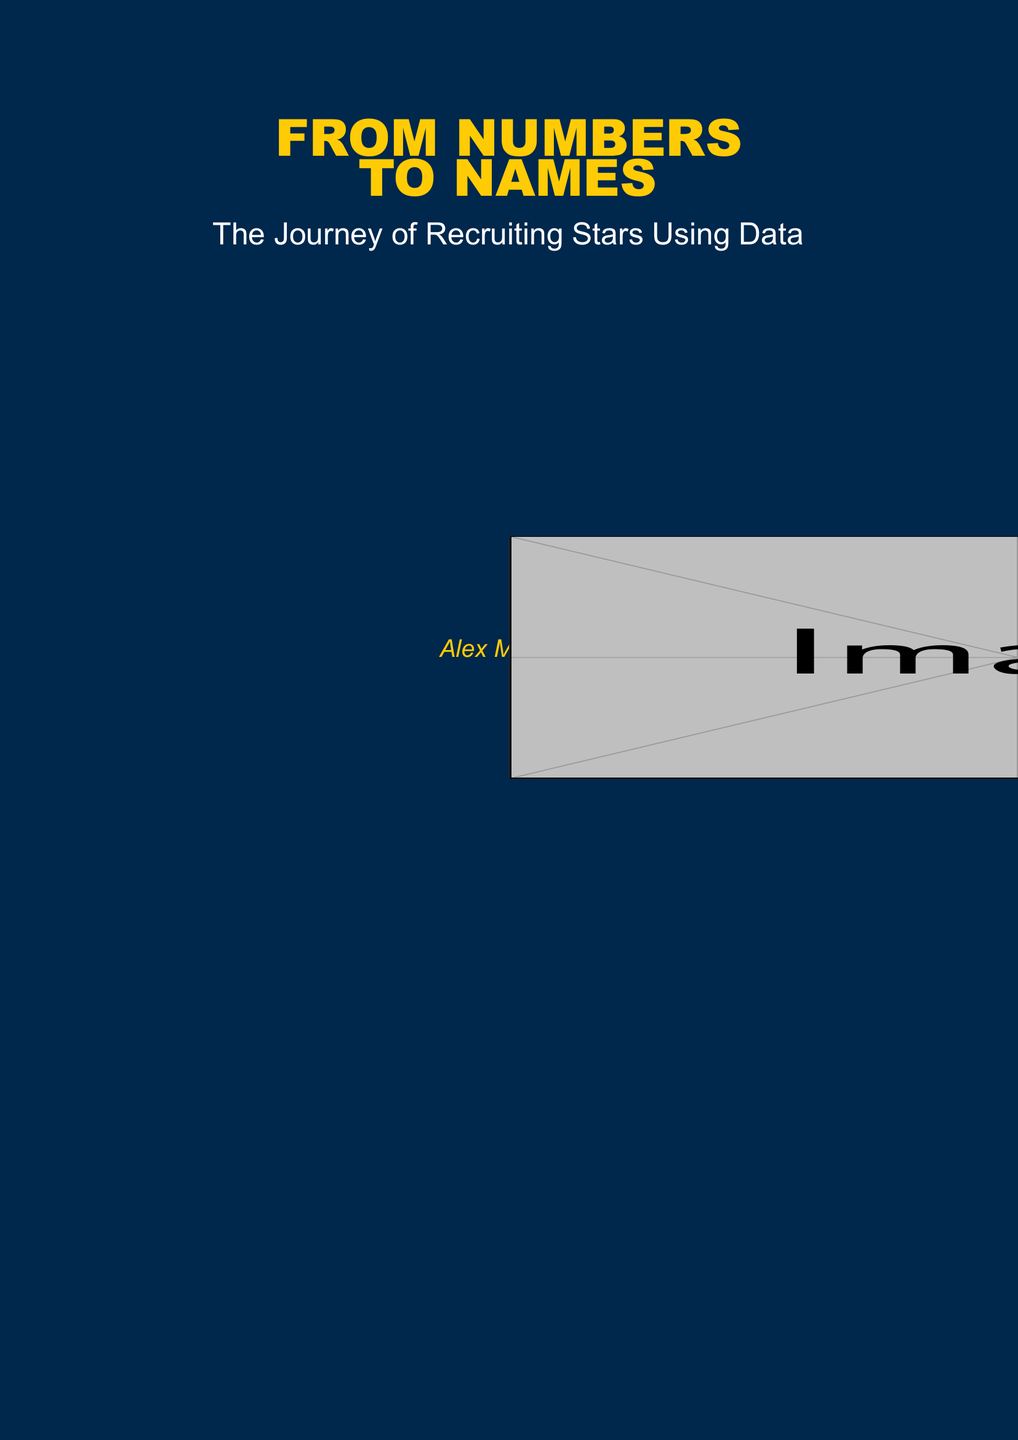What is the title of the book? The title of the book is prominently displayed in bold text on the cover.
Answer: FROM NUMBERS TO NAMES Who is the author of the book? The author's name appears in italics at the bottom of the cover.
Answer: Alex Morgan What color is the background of the book cover? The background color is specified at the beginning of the document as navy blue.
Answer: navy blue What is the subtitle of the book? The subtitle is located directly under the main title and provides insight into the book's content.
Answer: The Journey of Recruiting Stars Using Data What type of visual elements are featured on the cover? The document includes a description of a design element transitioning from player silhouettes to data points.
Answer: Player silhouettes transitioning into data points How many centimeters is the margin set in the document? The margin setting is specified in the geometry package at the beginning of the document.
Answer: 0 cm What font style is used for the main title? The font style for the title is mentioned as "Arial Black," indicating its boldness and prominence.
Answer: Arial Black What size is the main title of the book? The size of the title is indicated in the font size scaling instruction.
Answer: 2.5 What color is the subtitle text? The subtitle's color is mentioned clearly in the document, providing contrast against the background.
Answer: white What design software is used to create the visuals on the cover? The document utilizes a specific package for creating the design elements on the cover.
Answer: tikz 